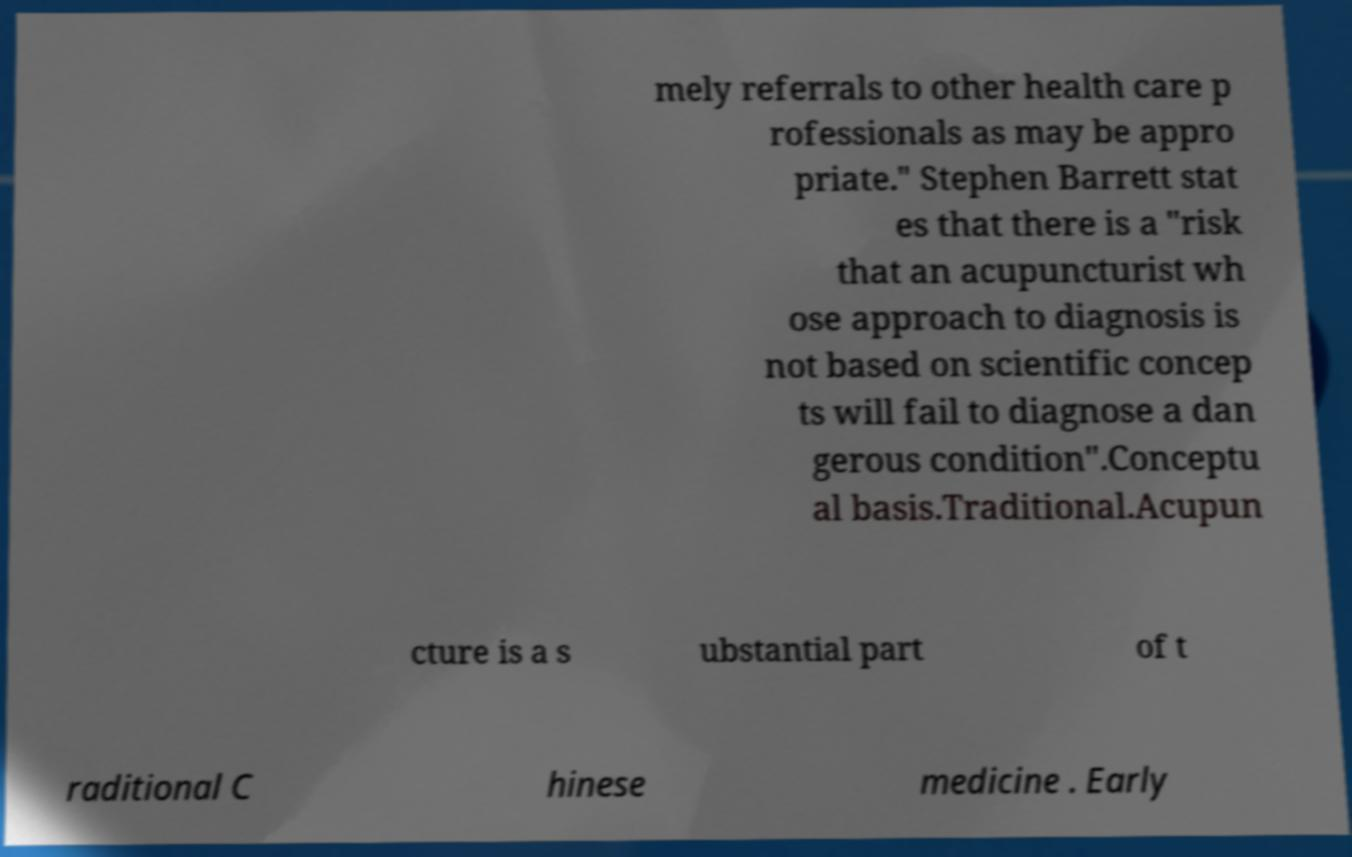What messages or text are displayed in this image? I need them in a readable, typed format. mely referrals to other health care p rofessionals as may be appro priate." Stephen Barrett stat es that there is a "risk that an acupuncturist wh ose approach to diagnosis is not based on scientific concep ts will fail to diagnose a dan gerous condition".Conceptu al basis.Traditional.Acupun cture is a s ubstantial part of t raditional C hinese medicine . Early 